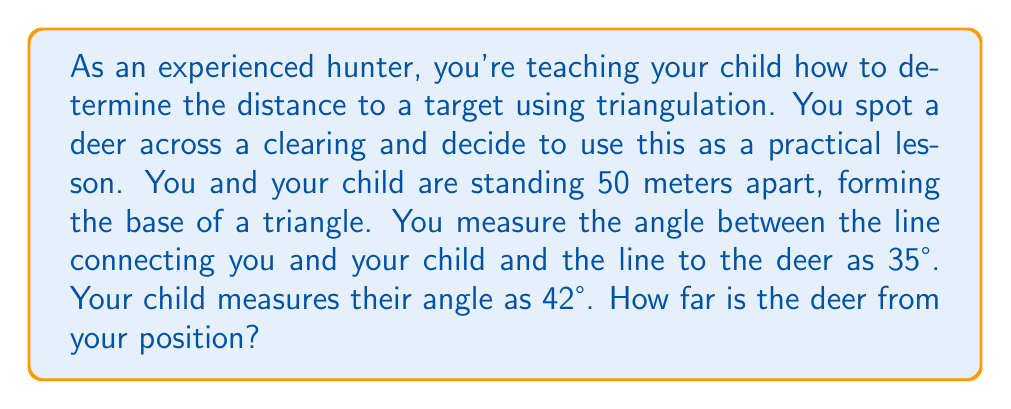Solve this math problem. Let's approach this step-by-step using the law of sines:

1) First, let's define our triangle:
   - Side a: the distance from you to the deer (what we're solving for)
   - Side b: the distance from your child to the deer
   - Side c: the distance between you and your child (50 meters)
   - Angle A: your angle (35°)
   - Angle B: your child's angle (42°)
   - Angle C: the angle at the deer (we'll calculate this)

2) We know that the sum of angles in a triangle is 180°, so:
   $$C = 180° - (A + B) = 180° - (35° + 42°) = 103°$$

3) Now we can use the law of sines:
   $$\frac{a}{\sin A} = \frac{b}{\sin B} = \frac{c}{\sin C}$$

4) We're interested in side a, so let's use:
   $$\frac{a}{\sin A} = \frac{c}{\sin C}$$

5) Rearranging to solve for a:
   $$a = \frac{c \sin A}{\sin C}$$

6) Now we can plug in our known values:
   $$a = \frac{50 \sin 35°}{\sin 103°}$$

7) Using a calculator (or trigonometric tables):
   $$a = \frac{50 \times 0.5736}{0.9744} \approx 29.45$$

Therefore, the deer is approximately 29.45 meters from your position.
Answer: $29.45$ meters 